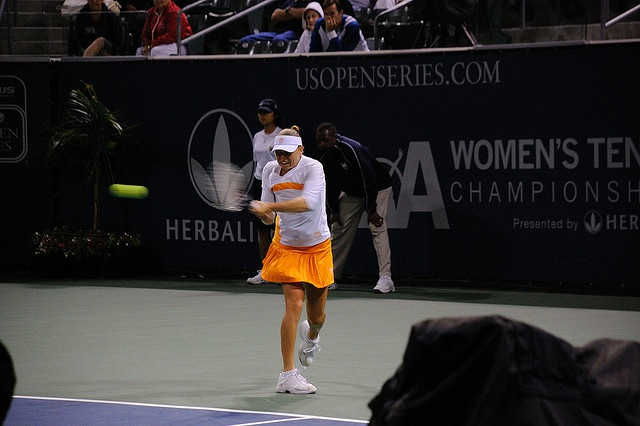Describe the objects in this image and their specific colors. I can see people in black, darkgray, brown, red, and orange tones, people in black and gray tones, people in black, darkgray, and gray tones, people in black, maroon, and gray tones, and people in black, gray, maroon, and navy tones in this image. 